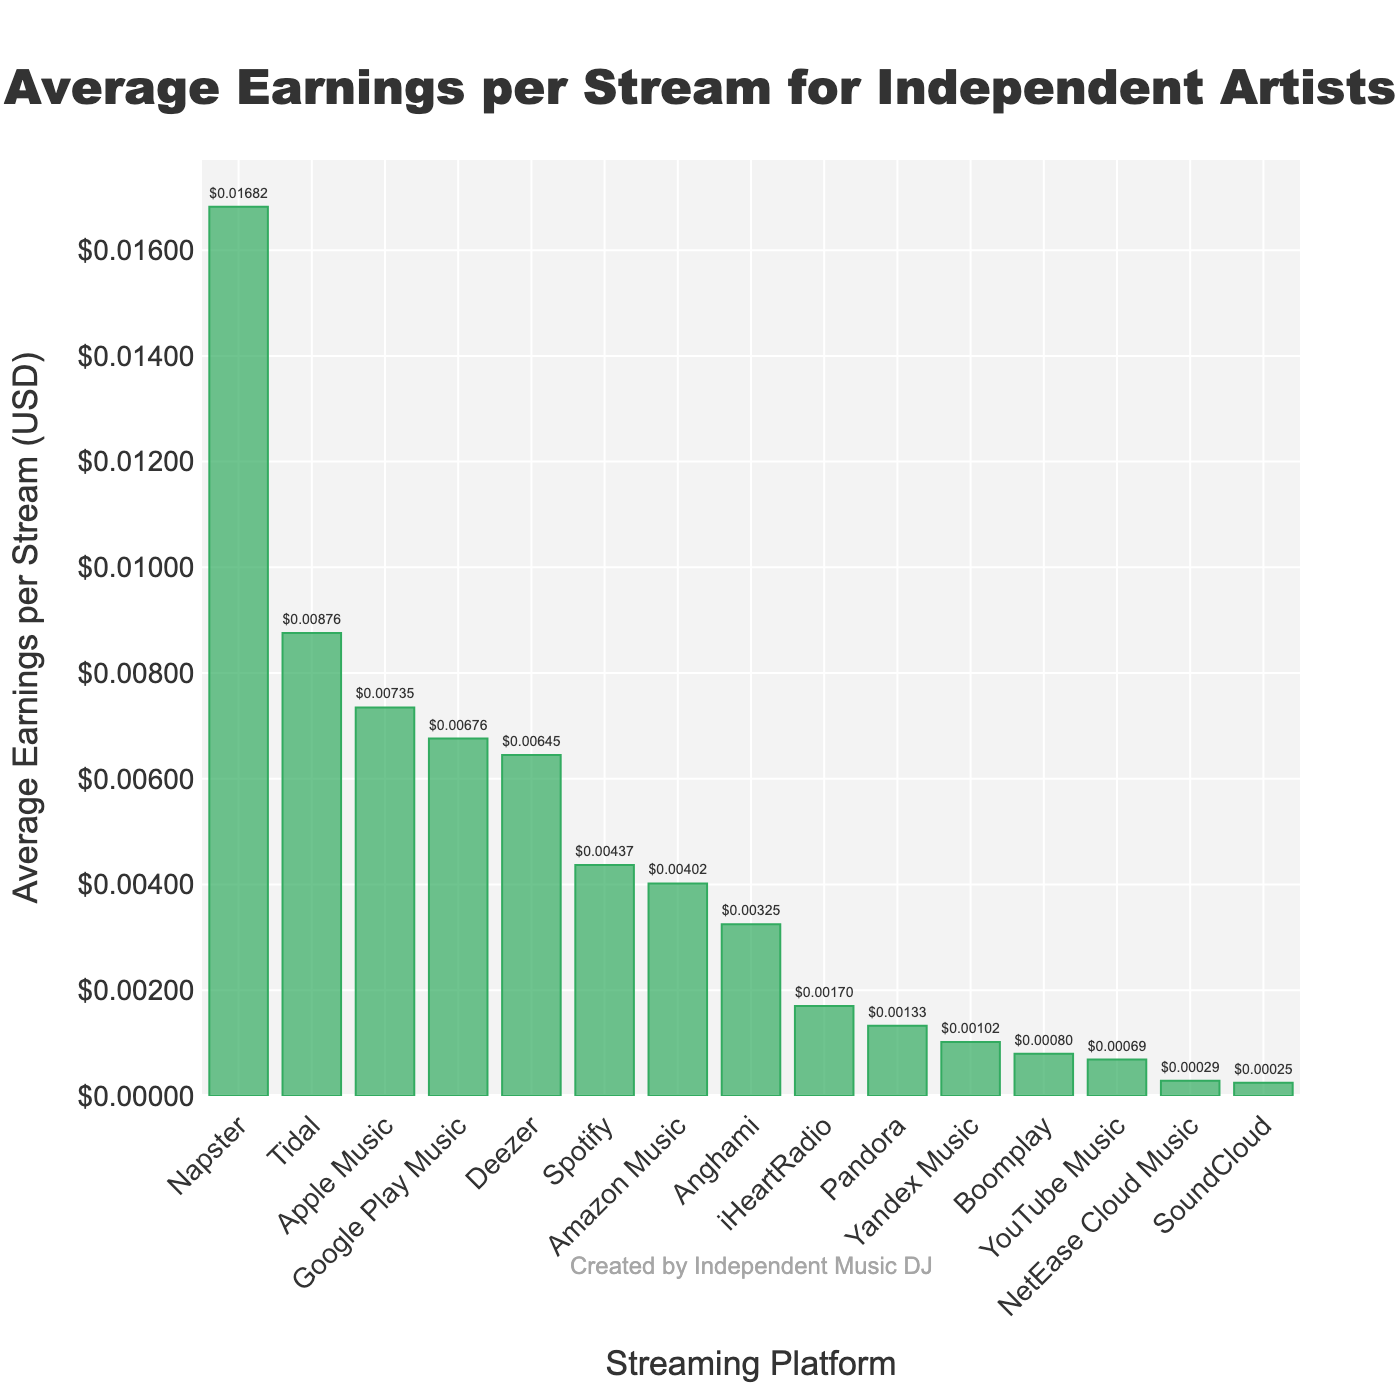Which platform offers the highest average earnings per stream? The bar corresponding to Napster is the tallest among all, indicating that Napster offers the highest average earnings per stream.
Answer: Napster Which platform offers the lowest average earnings per stream? The bar corresponding to SoundCloud is the shortest among all, indicating that SoundCloud offers the lowest average earnings per stream.
Answer: SoundCloud How do the average earnings per stream from Spotify compare to Apple Music? To compare, look at both bars. The Apple Music bar is higher than the Spotify bar, indicating that Apple Music offers higher average earnings per stream than Spotify.
Answer: Apple Music offers higher earnings than Spotify Between Tidal and Deezer, which platform offers more average earnings per stream and by how much? Look at the heights of the bars for Tidal and Deezer. Tidal's bar is higher than Deezer's bar. The difference in average earnings is calculated as $0.00876 - $0.00645 = $0.00231.
Answer: Tidal by $0.00231 What is the combined average earnings per stream for Amazon Music and Pandora? Sum the earnings for Amazon Music and Pandora. $0.00402 + $0.00133 = $0.00535.
Answer: $0.00535 Which platform falls exactly in the middle in terms of average earnings per stream? Arrange the platforms by average earnings in ascending order. The middle platform is the one which occupies the median position in the sorted list.
Answer: Anghami List the top three platforms with the highest average earnings per stream. Identify and list the three tallest bars: Napster, Tidal, and Apple Music.
Answer: Napster, Tidal, Apple Music What is the average earnings per stream for platforms that offer less than $0.002? Sum and then divide by the number of these platforms: ($0.00069 + $0.00133 + $0.00025 + $0.00170 + $0.00102 + $0.00080 + $0.00029) / 7. Calculation: (0.00069 + 0.00133 + 0.00025 + 0.00170 + 0.00102 + 0.00080 + 0.00029) / 7 = 0.00508 / 7.
Answer: $0.00073 Which platforms offer average earnings per stream above $0.01? Look at bars above the $0.01 mark: only Napster's bar is above this mark.
Answer: Napster If you add the average earnings per stream of Spotify, YouTube Music, and Pandora, what would it be? Sum the earnings for Spotify, YouTube Music, and Pandora. $0.00437 + $0.00069 + $0.00133 = $0.00639.
Answer: $0.00639 